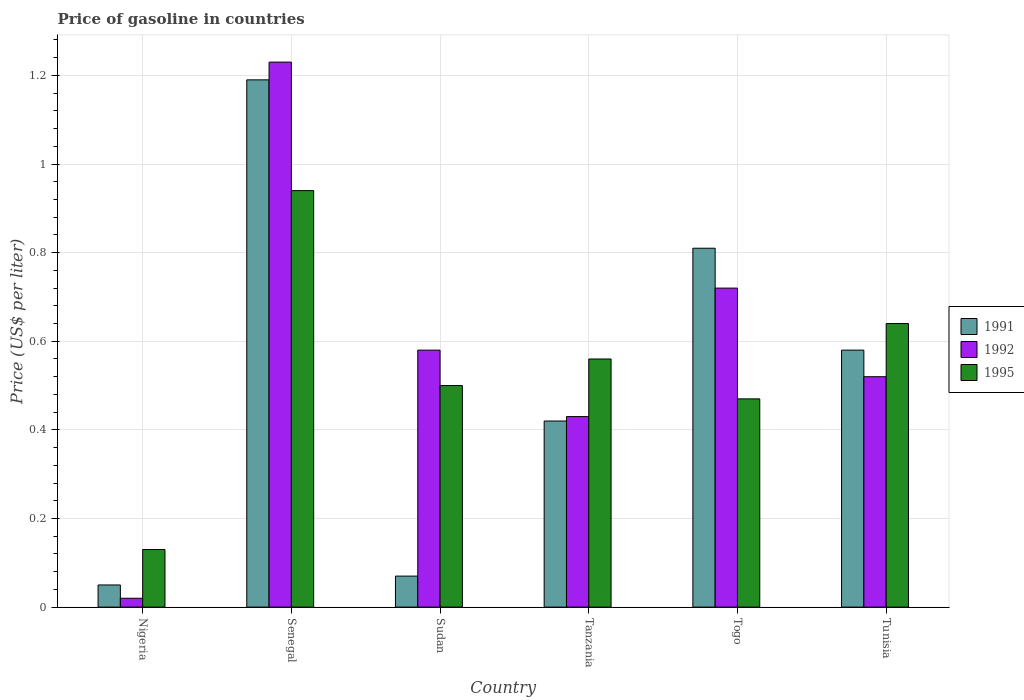How many different coloured bars are there?
Provide a short and direct response. 3. Are the number of bars on each tick of the X-axis equal?
Offer a terse response. Yes. How many bars are there on the 6th tick from the right?
Keep it short and to the point. 3. What is the label of the 2nd group of bars from the left?
Your answer should be very brief. Senegal. What is the price of gasoline in 1991 in Sudan?
Ensure brevity in your answer.  0.07. Across all countries, what is the maximum price of gasoline in 1991?
Offer a terse response. 1.19. Across all countries, what is the minimum price of gasoline in 1995?
Make the answer very short. 0.13. In which country was the price of gasoline in 1992 maximum?
Provide a succinct answer. Senegal. In which country was the price of gasoline in 1995 minimum?
Offer a terse response. Nigeria. What is the total price of gasoline in 1995 in the graph?
Give a very brief answer. 3.24. What is the difference between the price of gasoline in 1991 in Nigeria and that in Senegal?
Your answer should be very brief. -1.14. What is the difference between the price of gasoline in 1992 in Nigeria and the price of gasoline in 1995 in Togo?
Make the answer very short. -0.45. What is the average price of gasoline in 1995 per country?
Offer a terse response. 0.54. What is the difference between the price of gasoline of/in 1995 and price of gasoline of/in 1992 in Nigeria?
Provide a short and direct response. 0.11. What is the ratio of the price of gasoline in 1991 in Nigeria to that in Senegal?
Ensure brevity in your answer.  0.04. Is the difference between the price of gasoline in 1995 in Nigeria and Senegal greater than the difference between the price of gasoline in 1992 in Nigeria and Senegal?
Offer a terse response. Yes. What is the difference between the highest and the second highest price of gasoline in 1991?
Ensure brevity in your answer.  -0.38. What is the difference between the highest and the lowest price of gasoline in 1992?
Make the answer very short. 1.21. What does the 1st bar from the left in Senegal represents?
Your response must be concise. 1991. What does the 1st bar from the right in Senegal represents?
Give a very brief answer. 1995. Is it the case that in every country, the sum of the price of gasoline in 1992 and price of gasoline in 1991 is greater than the price of gasoline in 1995?
Your response must be concise. No. How many countries are there in the graph?
Provide a succinct answer. 6. Does the graph contain grids?
Make the answer very short. Yes. How many legend labels are there?
Give a very brief answer. 3. How are the legend labels stacked?
Provide a short and direct response. Vertical. What is the title of the graph?
Your answer should be compact. Price of gasoline in countries. Does "2014" appear as one of the legend labels in the graph?
Your response must be concise. No. What is the label or title of the X-axis?
Your answer should be very brief. Country. What is the label or title of the Y-axis?
Make the answer very short. Price (US$ per liter). What is the Price (US$ per liter) in 1991 in Nigeria?
Make the answer very short. 0.05. What is the Price (US$ per liter) in 1992 in Nigeria?
Your answer should be very brief. 0.02. What is the Price (US$ per liter) of 1995 in Nigeria?
Your answer should be very brief. 0.13. What is the Price (US$ per liter) in 1991 in Senegal?
Your answer should be compact. 1.19. What is the Price (US$ per liter) of 1992 in Senegal?
Provide a short and direct response. 1.23. What is the Price (US$ per liter) in 1995 in Senegal?
Provide a short and direct response. 0.94. What is the Price (US$ per liter) in 1991 in Sudan?
Your answer should be compact. 0.07. What is the Price (US$ per liter) of 1992 in Sudan?
Provide a short and direct response. 0.58. What is the Price (US$ per liter) in 1991 in Tanzania?
Your answer should be compact. 0.42. What is the Price (US$ per liter) of 1992 in Tanzania?
Provide a succinct answer. 0.43. What is the Price (US$ per liter) of 1995 in Tanzania?
Offer a terse response. 0.56. What is the Price (US$ per liter) of 1991 in Togo?
Your answer should be very brief. 0.81. What is the Price (US$ per liter) of 1992 in Togo?
Provide a short and direct response. 0.72. What is the Price (US$ per liter) in 1995 in Togo?
Offer a very short reply. 0.47. What is the Price (US$ per liter) of 1991 in Tunisia?
Offer a terse response. 0.58. What is the Price (US$ per liter) in 1992 in Tunisia?
Your answer should be very brief. 0.52. What is the Price (US$ per liter) in 1995 in Tunisia?
Keep it short and to the point. 0.64. Across all countries, what is the maximum Price (US$ per liter) in 1991?
Offer a very short reply. 1.19. Across all countries, what is the maximum Price (US$ per liter) of 1992?
Keep it short and to the point. 1.23. Across all countries, what is the maximum Price (US$ per liter) in 1995?
Your response must be concise. 0.94. Across all countries, what is the minimum Price (US$ per liter) in 1991?
Your answer should be very brief. 0.05. Across all countries, what is the minimum Price (US$ per liter) in 1995?
Your answer should be very brief. 0.13. What is the total Price (US$ per liter) of 1991 in the graph?
Your answer should be very brief. 3.12. What is the total Price (US$ per liter) of 1995 in the graph?
Provide a succinct answer. 3.24. What is the difference between the Price (US$ per liter) in 1991 in Nigeria and that in Senegal?
Offer a terse response. -1.14. What is the difference between the Price (US$ per liter) in 1992 in Nigeria and that in Senegal?
Provide a short and direct response. -1.21. What is the difference between the Price (US$ per liter) of 1995 in Nigeria and that in Senegal?
Provide a short and direct response. -0.81. What is the difference between the Price (US$ per liter) of 1991 in Nigeria and that in Sudan?
Provide a succinct answer. -0.02. What is the difference between the Price (US$ per liter) of 1992 in Nigeria and that in Sudan?
Offer a very short reply. -0.56. What is the difference between the Price (US$ per liter) of 1995 in Nigeria and that in Sudan?
Provide a succinct answer. -0.37. What is the difference between the Price (US$ per liter) of 1991 in Nigeria and that in Tanzania?
Provide a succinct answer. -0.37. What is the difference between the Price (US$ per liter) of 1992 in Nigeria and that in Tanzania?
Give a very brief answer. -0.41. What is the difference between the Price (US$ per liter) in 1995 in Nigeria and that in Tanzania?
Make the answer very short. -0.43. What is the difference between the Price (US$ per liter) of 1991 in Nigeria and that in Togo?
Keep it short and to the point. -0.76. What is the difference between the Price (US$ per liter) of 1992 in Nigeria and that in Togo?
Your answer should be compact. -0.7. What is the difference between the Price (US$ per liter) of 1995 in Nigeria and that in Togo?
Your answer should be compact. -0.34. What is the difference between the Price (US$ per liter) of 1991 in Nigeria and that in Tunisia?
Provide a succinct answer. -0.53. What is the difference between the Price (US$ per liter) of 1995 in Nigeria and that in Tunisia?
Keep it short and to the point. -0.51. What is the difference between the Price (US$ per liter) of 1991 in Senegal and that in Sudan?
Give a very brief answer. 1.12. What is the difference between the Price (US$ per liter) of 1992 in Senegal and that in Sudan?
Offer a terse response. 0.65. What is the difference between the Price (US$ per liter) of 1995 in Senegal and that in Sudan?
Offer a terse response. 0.44. What is the difference between the Price (US$ per liter) of 1991 in Senegal and that in Tanzania?
Offer a very short reply. 0.77. What is the difference between the Price (US$ per liter) of 1992 in Senegal and that in Tanzania?
Offer a very short reply. 0.8. What is the difference between the Price (US$ per liter) of 1995 in Senegal and that in Tanzania?
Ensure brevity in your answer.  0.38. What is the difference between the Price (US$ per liter) of 1991 in Senegal and that in Togo?
Your answer should be compact. 0.38. What is the difference between the Price (US$ per liter) of 1992 in Senegal and that in Togo?
Make the answer very short. 0.51. What is the difference between the Price (US$ per liter) in 1995 in Senegal and that in Togo?
Keep it short and to the point. 0.47. What is the difference between the Price (US$ per liter) in 1991 in Senegal and that in Tunisia?
Keep it short and to the point. 0.61. What is the difference between the Price (US$ per liter) of 1992 in Senegal and that in Tunisia?
Offer a terse response. 0.71. What is the difference between the Price (US$ per liter) in 1991 in Sudan and that in Tanzania?
Your response must be concise. -0.35. What is the difference between the Price (US$ per liter) of 1995 in Sudan and that in Tanzania?
Give a very brief answer. -0.06. What is the difference between the Price (US$ per liter) of 1991 in Sudan and that in Togo?
Your response must be concise. -0.74. What is the difference between the Price (US$ per liter) of 1992 in Sudan and that in Togo?
Offer a terse response. -0.14. What is the difference between the Price (US$ per liter) in 1995 in Sudan and that in Togo?
Ensure brevity in your answer.  0.03. What is the difference between the Price (US$ per liter) of 1991 in Sudan and that in Tunisia?
Make the answer very short. -0.51. What is the difference between the Price (US$ per liter) of 1995 in Sudan and that in Tunisia?
Provide a succinct answer. -0.14. What is the difference between the Price (US$ per liter) of 1991 in Tanzania and that in Togo?
Make the answer very short. -0.39. What is the difference between the Price (US$ per liter) in 1992 in Tanzania and that in Togo?
Your response must be concise. -0.29. What is the difference between the Price (US$ per liter) in 1995 in Tanzania and that in Togo?
Your answer should be very brief. 0.09. What is the difference between the Price (US$ per liter) of 1991 in Tanzania and that in Tunisia?
Give a very brief answer. -0.16. What is the difference between the Price (US$ per liter) of 1992 in Tanzania and that in Tunisia?
Your response must be concise. -0.09. What is the difference between the Price (US$ per liter) of 1995 in Tanzania and that in Tunisia?
Keep it short and to the point. -0.08. What is the difference between the Price (US$ per liter) of 1991 in Togo and that in Tunisia?
Keep it short and to the point. 0.23. What is the difference between the Price (US$ per liter) in 1995 in Togo and that in Tunisia?
Make the answer very short. -0.17. What is the difference between the Price (US$ per liter) of 1991 in Nigeria and the Price (US$ per liter) of 1992 in Senegal?
Keep it short and to the point. -1.18. What is the difference between the Price (US$ per liter) of 1991 in Nigeria and the Price (US$ per liter) of 1995 in Senegal?
Give a very brief answer. -0.89. What is the difference between the Price (US$ per liter) in 1992 in Nigeria and the Price (US$ per liter) in 1995 in Senegal?
Offer a terse response. -0.92. What is the difference between the Price (US$ per liter) in 1991 in Nigeria and the Price (US$ per liter) in 1992 in Sudan?
Offer a terse response. -0.53. What is the difference between the Price (US$ per liter) of 1991 in Nigeria and the Price (US$ per liter) of 1995 in Sudan?
Give a very brief answer. -0.45. What is the difference between the Price (US$ per liter) of 1992 in Nigeria and the Price (US$ per liter) of 1995 in Sudan?
Provide a succinct answer. -0.48. What is the difference between the Price (US$ per liter) in 1991 in Nigeria and the Price (US$ per liter) in 1992 in Tanzania?
Your answer should be very brief. -0.38. What is the difference between the Price (US$ per liter) of 1991 in Nigeria and the Price (US$ per liter) of 1995 in Tanzania?
Ensure brevity in your answer.  -0.51. What is the difference between the Price (US$ per liter) of 1992 in Nigeria and the Price (US$ per liter) of 1995 in Tanzania?
Offer a very short reply. -0.54. What is the difference between the Price (US$ per liter) of 1991 in Nigeria and the Price (US$ per liter) of 1992 in Togo?
Give a very brief answer. -0.67. What is the difference between the Price (US$ per liter) of 1991 in Nigeria and the Price (US$ per liter) of 1995 in Togo?
Give a very brief answer. -0.42. What is the difference between the Price (US$ per liter) of 1992 in Nigeria and the Price (US$ per liter) of 1995 in Togo?
Make the answer very short. -0.45. What is the difference between the Price (US$ per liter) of 1991 in Nigeria and the Price (US$ per liter) of 1992 in Tunisia?
Provide a short and direct response. -0.47. What is the difference between the Price (US$ per liter) in 1991 in Nigeria and the Price (US$ per liter) in 1995 in Tunisia?
Your response must be concise. -0.59. What is the difference between the Price (US$ per liter) of 1992 in Nigeria and the Price (US$ per liter) of 1995 in Tunisia?
Make the answer very short. -0.62. What is the difference between the Price (US$ per liter) in 1991 in Senegal and the Price (US$ per liter) in 1992 in Sudan?
Ensure brevity in your answer.  0.61. What is the difference between the Price (US$ per liter) of 1991 in Senegal and the Price (US$ per liter) of 1995 in Sudan?
Offer a very short reply. 0.69. What is the difference between the Price (US$ per liter) in 1992 in Senegal and the Price (US$ per liter) in 1995 in Sudan?
Ensure brevity in your answer.  0.73. What is the difference between the Price (US$ per liter) in 1991 in Senegal and the Price (US$ per liter) in 1992 in Tanzania?
Keep it short and to the point. 0.76. What is the difference between the Price (US$ per liter) in 1991 in Senegal and the Price (US$ per liter) in 1995 in Tanzania?
Provide a short and direct response. 0.63. What is the difference between the Price (US$ per liter) in 1992 in Senegal and the Price (US$ per liter) in 1995 in Tanzania?
Your answer should be compact. 0.67. What is the difference between the Price (US$ per liter) of 1991 in Senegal and the Price (US$ per liter) of 1992 in Togo?
Give a very brief answer. 0.47. What is the difference between the Price (US$ per liter) in 1991 in Senegal and the Price (US$ per liter) in 1995 in Togo?
Your response must be concise. 0.72. What is the difference between the Price (US$ per liter) in 1992 in Senegal and the Price (US$ per liter) in 1995 in Togo?
Give a very brief answer. 0.76. What is the difference between the Price (US$ per liter) of 1991 in Senegal and the Price (US$ per liter) of 1992 in Tunisia?
Offer a very short reply. 0.67. What is the difference between the Price (US$ per liter) in 1991 in Senegal and the Price (US$ per liter) in 1995 in Tunisia?
Your answer should be very brief. 0.55. What is the difference between the Price (US$ per liter) of 1992 in Senegal and the Price (US$ per liter) of 1995 in Tunisia?
Give a very brief answer. 0.59. What is the difference between the Price (US$ per liter) in 1991 in Sudan and the Price (US$ per liter) in 1992 in Tanzania?
Your response must be concise. -0.36. What is the difference between the Price (US$ per liter) in 1991 in Sudan and the Price (US$ per liter) in 1995 in Tanzania?
Give a very brief answer. -0.49. What is the difference between the Price (US$ per liter) in 1991 in Sudan and the Price (US$ per liter) in 1992 in Togo?
Offer a terse response. -0.65. What is the difference between the Price (US$ per liter) in 1991 in Sudan and the Price (US$ per liter) in 1995 in Togo?
Your response must be concise. -0.4. What is the difference between the Price (US$ per liter) in 1992 in Sudan and the Price (US$ per liter) in 1995 in Togo?
Make the answer very short. 0.11. What is the difference between the Price (US$ per liter) in 1991 in Sudan and the Price (US$ per liter) in 1992 in Tunisia?
Make the answer very short. -0.45. What is the difference between the Price (US$ per liter) of 1991 in Sudan and the Price (US$ per liter) of 1995 in Tunisia?
Your answer should be very brief. -0.57. What is the difference between the Price (US$ per liter) of 1992 in Sudan and the Price (US$ per liter) of 1995 in Tunisia?
Provide a short and direct response. -0.06. What is the difference between the Price (US$ per liter) in 1991 in Tanzania and the Price (US$ per liter) in 1992 in Togo?
Your response must be concise. -0.3. What is the difference between the Price (US$ per liter) in 1992 in Tanzania and the Price (US$ per liter) in 1995 in Togo?
Provide a short and direct response. -0.04. What is the difference between the Price (US$ per liter) of 1991 in Tanzania and the Price (US$ per liter) of 1995 in Tunisia?
Your response must be concise. -0.22. What is the difference between the Price (US$ per liter) of 1992 in Tanzania and the Price (US$ per liter) of 1995 in Tunisia?
Your response must be concise. -0.21. What is the difference between the Price (US$ per liter) in 1991 in Togo and the Price (US$ per liter) in 1992 in Tunisia?
Offer a terse response. 0.29. What is the difference between the Price (US$ per liter) of 1991 in Togo and the Price (US$ per liter) of 1995 in Tunisia?
Ensure brevity in your answer.  0.17. What is the average Price (US$ per liter) of 1991 per country?
Offer a terse response. 0.52. What is the average Price (US$ per liter) of 1992 per country?
Offer a terse response. 0.58. What is the average Price (US$ per liter) of 1995 per country?
Your answer should be very brief. 0.54. What is the difference between the Price (US$ per liter) in 1991 and Price (US$ per liter) in 1992 in Nigeria?
Give a very brief answer. 0.03. What is the difference between the Price (US$ per liter) in 1991 and Price (US$ per liter) in 1995 in Nigeria?
Provide a succinct answer. -0.08. What is the difference between the Price (US$ per liter) in 1992 and Price (US$ per liter) in 1995 in Nigeria?
Your response must be concise. -0.11. What is the difference between the Price (US$ per liter) in 1991 and Price (US$ per liter) in 1992 in Senegal?
Keep it short and to the point. -0.04. What is the difference between the Price (US$ per liter) of 1992 and Price (US$ per liter) of 1995 in Senegal?
Your answer should be very brief. 0.29. What is the difference between the Price (US$ per liter) in 1991 and Price (US$ per liter) in 1992 in Sudan?
Keep it short and to the point. -0.51. What is the difference between the Price (US$ per liter) of 1991 and Price (US$ per liter) of 1995 in Sudan?
Your response must be concise. -0.43. What is the difference between the Price (US$ per liter) in 1991 and Price (US$ per liter) in 1992 in Tanzania?
Your response must be concise. -0.01. What is the difference between the Price (US$ per liter) in 1991 and Price (US$ per liter) in 1995 in Tanzania?
Ensure brevity in your answer.  -0.14. What is the difference between the Price (US$ per liter) of 1992 and Price (US$ per liter) of 1995 in Tanzania?
Provide a short and direct response. -0.13. What is the difference between the Price (US$ per liter) of 1991 and Price (US$ per liter) of 1992 in Togo?
Offer a terse response. 0.09. What is the difference between the Price (US$ per liter) of 1991 and Price (US$ per liter) of 1995 in Togo?
Offer a terse response. 0.34. What is the difference between the Price (US$ per liter) of 1992 and Price (US$ per liter) of 1995 in Togo?
Ensure brevity in your answer.  0.25. What is the difference between the Price (US$ per liter) of 1991 and Price (US$ per liter) of 1992 in Tunisia?
Your response must be concise. 0.06. What is the difference between the Price (US$ per liter) in 1991 and Price (US$ per liter) in 1995 in Tunisia?
Your response must be concise. -0.06. What is the difference between the Price (US$ per liter) of 1992 and Price (US$ per liter) of 1995 in Tunisia?
Keep it short and to the point. -0.12. What is the ratio of the Price (US$ per liter) of 1991 in Nigeria to that in Senegal?
Keep it short and to the point. 0.04. What is the ratio of the Price (US$ per liter) in 1992 in Nigeria to that in Senegal?
Provide a succinct answer. 0.02. What is the ratio of the Price (US$ per liter) of 1995 in Nigeria to that in Senegal?
Ensure brevity in your answer.  0.14. What is the ratio of the Price (US$ per liter) in 1992 in Nigeria to that in Sudan?
Your response must be concise. 0.03. What is the ratio of the Price (US$ per liter) of 1995 in Nigeria to that in Sudan?
Give a very brief answer. 0.26. What is the ratio of the Price (US$ per liter) in 1991 in Nigeria to that in Tanzania?
Your response must be concise. 0.12. What is the ratio of the Price (US$ per liter) in 1992 in Nigeria to that in Tanzania?
Offer a very short reply. 0.05. What is the ratio of the Price (US$ per liter) in 1995 in Nigeria to that in Tanzania?
Offer a very short reply. 0.23. What is the ratio of the Price (US$ per liter) in 1991 in Nigeria to that in Togo?
Make the answer very short. 0.06. What is the ratio of the Price (US$ per liter) in 1992 in Nigeria to that in Togo?
Offer a very short reply. 0.03. What is the ratio of the Price (US$ per liter) in 1995 in Nigeria to that in Togo?
Offer a very short reply. 0.28. What is the ratio of the Price (US$ per liter) of 1991 in Nigeria to that in Tunisia?
Provide a short and direct response. 0.09. What is the ratio of the Price (US$ per liter) of 1992 in Nigeria to that in Tunisia?
Ensure brevity in your answer.  0.04. What is the ratio of the Price (US$ per liter) in 1995 in Nigeria to that in Tunisia?
Your response must be concise. 0.2. What is the ratio of the Price (US$ per liter) of 1992 in Senegal to that in Sudan?
Provide a succinct answer. 2.12. What is the ratio of the Price (US$ per liter) in 1995 in Senegal to that in Sudan?
Offer a terse response. 1.88. What is the ratio of the Price (US$ per liter) of 1991 in Senegal to that in Tanzania?
Keep it short and to the point. 2.83. What is the ratio of the Price (US$ per liter) in 1992 in Senegal to that in Tanzania?
Offer a terse response. 2.86. What is the ratio of the Price (US$ per liter) of 1995 in Senegal to that in Tanzania?
Offer a terse response. 1.68. What is the ratio of the Price (US$ per liter) in 1991 in Senegal to that in Togo?
Keep it short and to the point. 1.47. What is the ratio of the Price (US$ per liter) of 1992 in Senegal to that in Togo?
Provide a short and direct response. 1.71. What is the ratio of the Price (US$ per liter) of 1995 in Senegal to that in Togo?
Provide a succinct answer. 2. What is the ratio of the Price (US$ per liter) in 1991 in Senegal to that in Tunisia?
Provide a short and direct response. 2.05. What is the ratio of the Price (US$ per liter) in 1992 in Senegal to that in Tunisia?
Provide a short and direct response. 2.37. What is the ratio of the Price (US$ per liter) of 1995 in Senegal to that in Tunisia?
Offer a terse response. 1.47. What is the ratio of the Price (US$ per liter) in 1992 in Sudan to that in Tanzania?
Keep it short and to the point. 1.35. What is the ratio of the Price (US$ per liter) in 1995 in Sudan to that in Tanzania?
Your answer should be compact. 0.89. What is the ratio of the Price (US$ per liter) in 1991 in Sudan to that in Togo?
Ensure brevity in your answer.  0.09. What is the ratio of the Price (US$ per liter) in 1992 in Sudan to that in Togo?
Ensure brevity in your answer.  0.81. What is the ratio of the Price (US$ per liter) in 1995 in Sudan to that in Togo?
Ensure brevity in your answer.  1.06. What is the ratio of the Price (US$ per liter) in 1991 in Sudan to that in Tunisia?
Provide a short and direct response. 0.12. What is the ratio of the Price (US$ per liter) in 1992 in Sudan to that in Tunisia?
Provide a short and direct response. 1.12. What is the ratio of the Price (US$ per liter) of 1995 in Sudan to that in Tunisia?
Ensure brevity in your answer.  0.78. What is the ratio of the Price (US$ per liter) of 1991 in Tanzania to that in Togo?
Make the answer very short. 0.52. What is the ratio of the Price (US$ per liter) of 1992 in Tanzania to that in Togo?
Offer a very short reply. 0.6. What is the ratio of the Price (US$ per liter) of 1995 in Tanzania to that in Togo?
Your response must be concise. 1.19. What is the ratio of the Price (US$ per liter) of 1991 in Tanzania to that in Tunisia?
Your response must be concise. 0.72. What is the ratio of the Price (US$ per liter) of 1992 in Tanzania to that in Tunisia?
Give a very brief answer. 0.83. What is the ratio of the Price (US$ per liter) in 1995 in Tanzania to that in Tunisia?
Your answer should be very brief. 0.88. What is the ratio of the Price (US$ per liter) of 1991 in Togo to that in Tunisia?
Ensure brevity in your answer.  1.4. What is the ratio of the Price (US$ per liter) of 1992 in Togo to that in Tunisia?
Make the answer very short. 1.38. What is the ratio of the Price (US$ per liter) of 1995 in Togo to that in Tunisia?
Your answer should be compact. 0.73. What is the difference between the highest and the second highest Price (US$ per liter) in 1991?
Provide a short and direct response. 0.38. What is the difference between the highest and the second highest Price (US$ per liter) of 1992?
Offer a terse response. 0.51. What is the difference between the highest and the second highest Price (US$ per liter) in 1995?
Your answer should be very brief. 0.3. What is the difference between the highest and the lowest Price (US$ per liter) of 1991?
Provide a succinct answer. 1.14. What is the difference between the highest and the lowest Price (US$ per liter) in 1992?
Provide a succinct answer. 1.21. What is the difference between the highest and the lowest Price (US$ per liter) of 1995?
Provide a short and direct response. 0.81. 